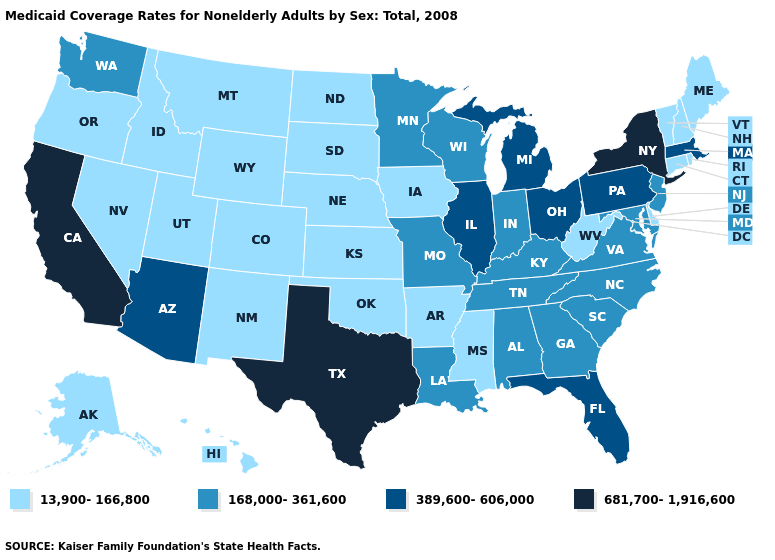Name the states that have a value in the range 13,900-166,800?
Concise answer only. Alaska, Arkansas, Colorado, Connecticut, Delaware, Hawaii, Idaho, Iowa, Kansas, Maine, Mississippi, Montana, Nebraska, Nevada, New Hampshire, New Mexico, North Dakota, Oklahoma, Oregon, Rhode Island, South Dakota, Utah, Vermont, West Virginia, Wyoming. Name the states that have a value in the range 389,600-606,000?
Keep it brief. Arizona, Florida, Illinois, Massachusetts, Michigan, Ohio, Pennsylvania. Name the states that have a value in the range 13,900-166,800?
Give a very brief answer. Alaska, Arkansas, Colorado, Connecticut, Delaware, Hawaii, Idaho, Iowa, Kansas, Maine, Mississippi, Montana, Nebraska, Nevada, New Hampshire, New Mexico, North Dakota, Oklahoma, Oregon, Rhode Island, South Dakota, Utah, Vermont, West Virginia, Wyoming. Which states have the lowest value in the MidWest?
Be succinct. Iowa, Kansas, Nebraska, North Dakota, South Dakota. What is the value of Tennessee?
Short answer required. 168,000-361,600. Among the states that border California , which have the lowest value?
Be succinct. Nevada, Oregon. What is the highest value in the USA?
Concise answer only. 681,700-1,916,600. What is the value of Maine?
Answer briefly. 13,900-166,800. What is the lowest value in states that border Montana?
Concise answer only. 13,900-166,800. Among the states that border Arkansas , does Mississippi have the lowest value?
Short answer required. Yes. What is the value of Montana?
Give a very brief answer. 13,900-166,800. Does California have the highest value in the West?
Concise answer only. Yes. Does Indiana have a higher value than Maine?
Write a very short answer. Yes. What is the value of Maryland?
Write a very short answer. 168,000-361,600. 